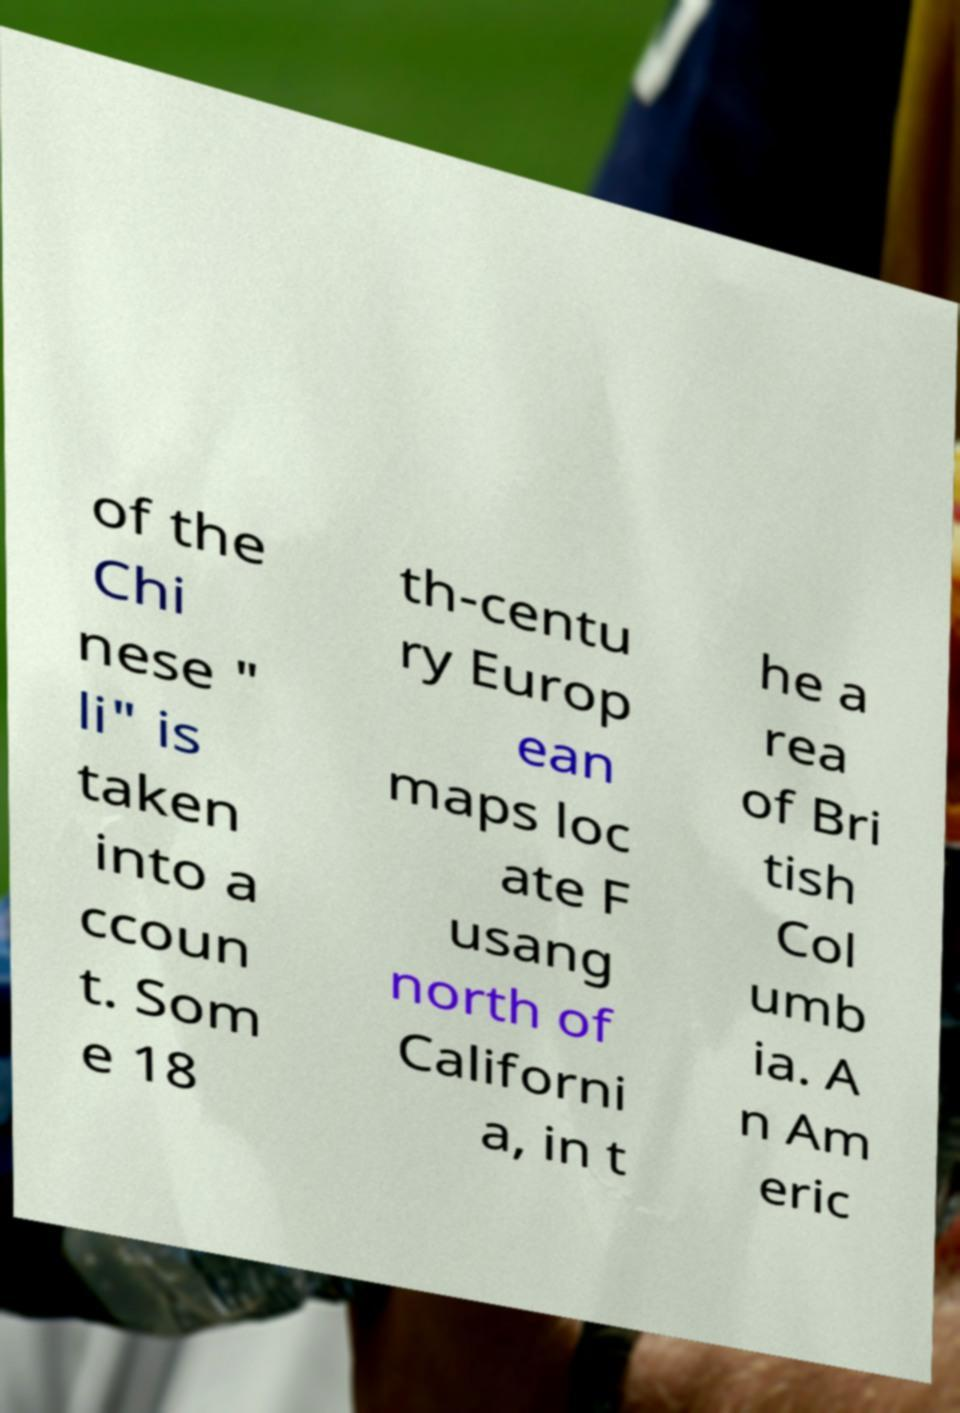Can you accurately transcribe the text from the provided image for me? of the Chi nese " li" is taken into a ccoun t. Som e 18 th-centu ry Europ ean maps loc ate F usang north of Californi a, in t he a rea of Bri tish Col umb ia. A n Am eric 